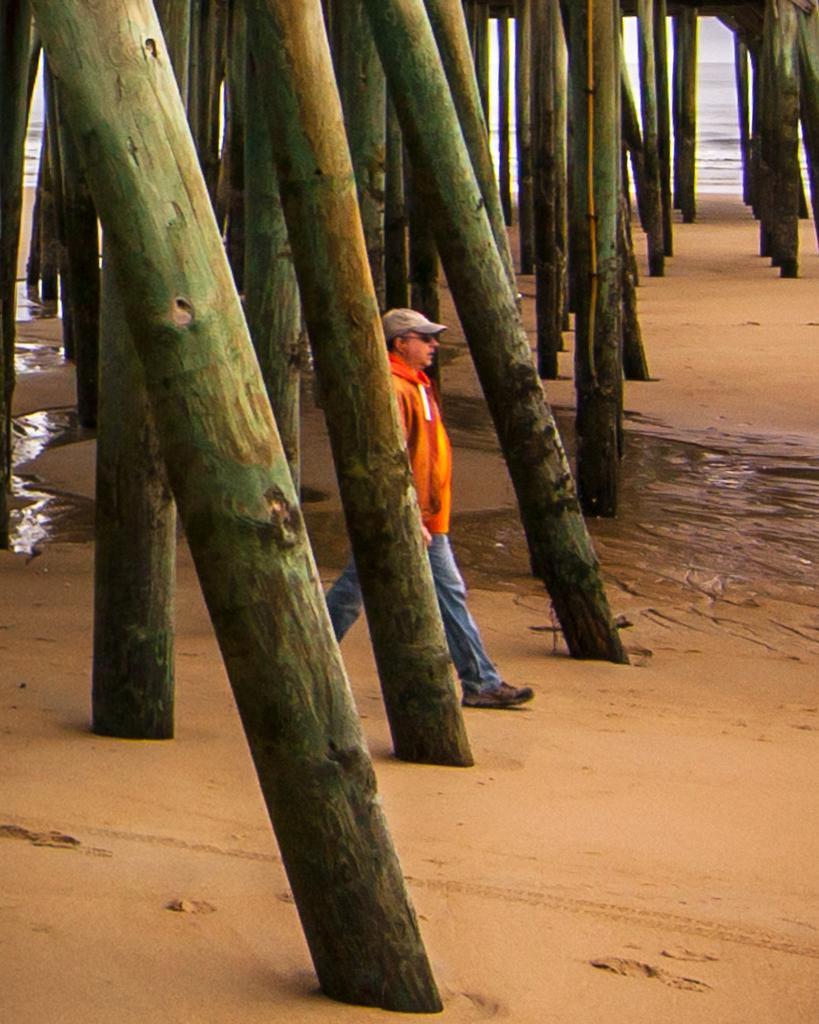In one or two sentences, can you explain what this image depicts? In this image there is a man walking on sand and there are wooden poles, in the background there is a sea. 